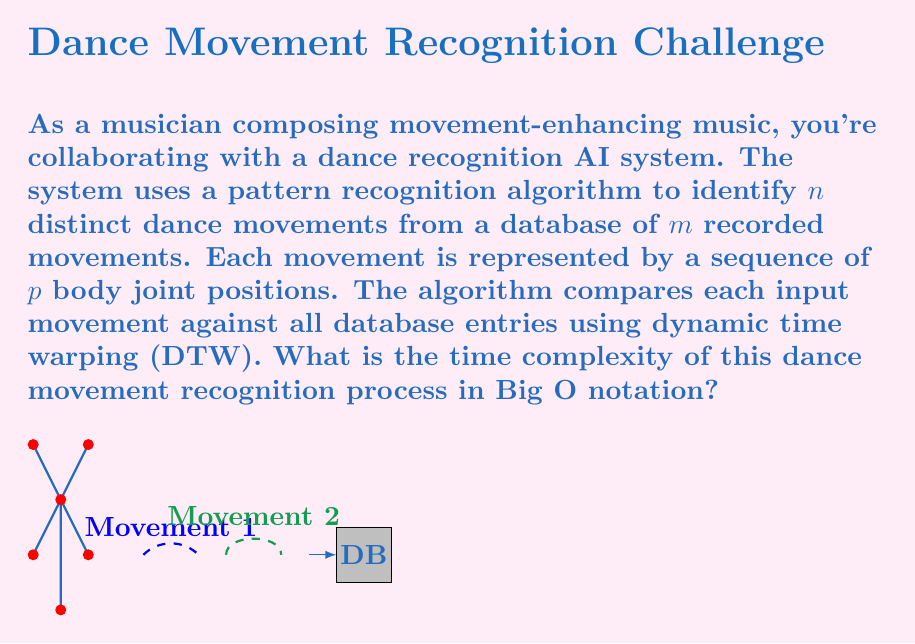Could you help me with this problem? Let's break down the problem and analyze the complexity step by step:

1) We have n input movements to recognize, m database movements, and each movement has p joint positions.

2) For each input movement, we need to compare it against all m database movements. This gives us a factor of n * m comparisons.

3) Each comparison uses the Dynamic Time Warping (DTW) algorithm. The time complexity of DTW for two sequences of length p is O(p^2).

4) Therefore, for each of the n * m comparisons, we perform a DTW operation of complexity O(p^2).

5) Combining these factors, we get:

   $$O(n * m * p^2)$$

6) This represents the overall time complexity of the dance movement recognition process.

Note: This analysis assumes a basic implementation of DTW. There are optimized versions of DTW that can reduce the complexity, but they are not considered in this basic scenario.
Answer: $$O(nmp^2)$$ 